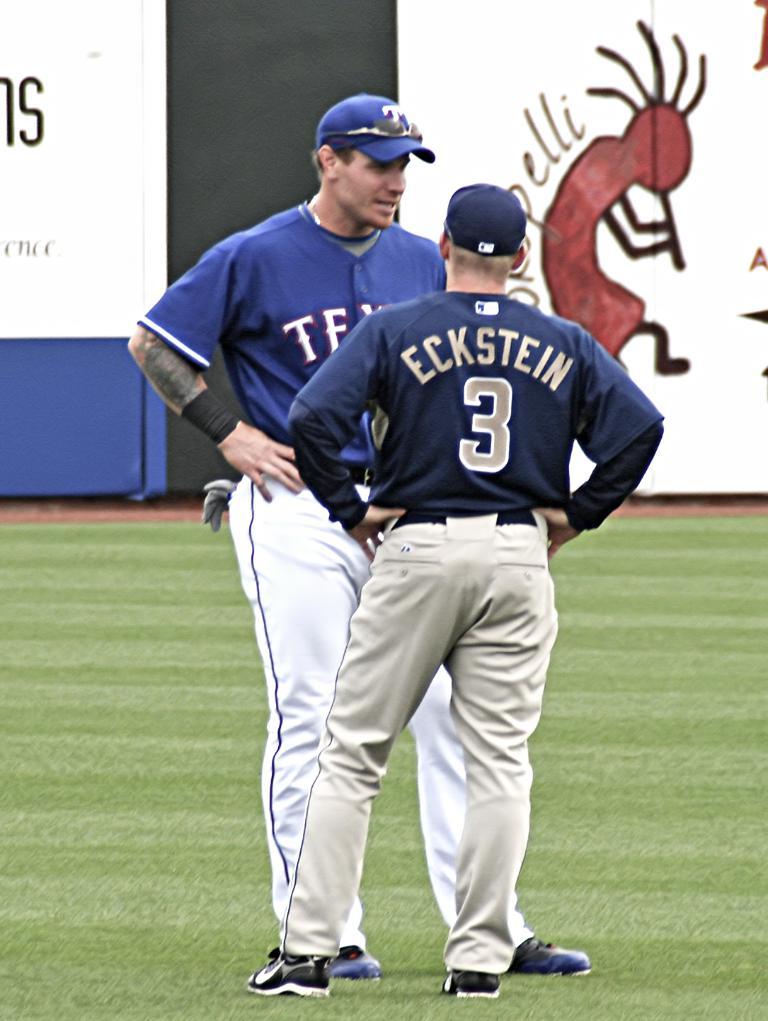What player number is eckstein?
Offer a terse response. 3. What state do you think the player on the left plays for?
Offer a very short reply. Texas. 